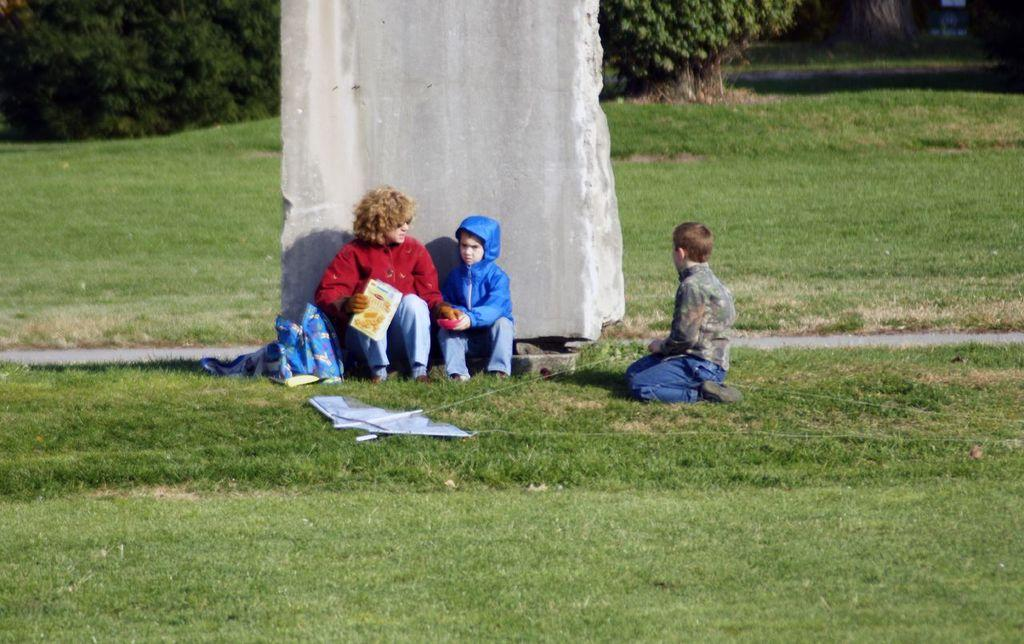What type of surface is at the bottom of the image? There is grass on the ground at the bottom of the image. How many people are sitting in the image? There are three persons sitting in the image. What is located behind the persons? There is a stone pillar behind the persons. What can be seen behind the stone pillar? There are trees behind the stone pillar. Can you see the uncle sitting with the group in the image? There is no mention of an uncle in the image, so we cannot determine if one is present. 